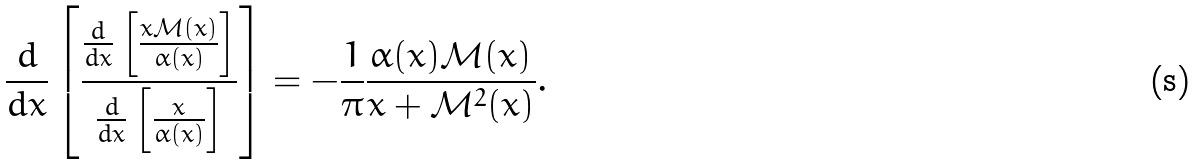Convert formula to latex. <formula><loc_0><loc_0><loc_500><loc_500>\frac { d } { d x } \left [ \frac { \frac { d } { d x } \left [ \frac { x { \mathcal { M } } ( x ) } { \alpha ( x ) } \right ] } { \frac { d } { d x } \left [ \frac { x } { \alpha ( x ) } \right ] } \right ] = - \frac { 1 } { \pi } \frac { \alpha ( x ) { \mathcal { M } } ( x ) } { x + { \mathcal { M } } ^ { 2 } ( x ) } .</formula> 